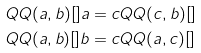<formula> <loc_0><loc_0><loc_500><loc_500>Q Q ( a , b ) [ ] a = c & Q Q ( c , b ) [ ] \\ Q Q ( a , b ) [ ] b = c & Q Q ( a , c ) [ ]</formula> 